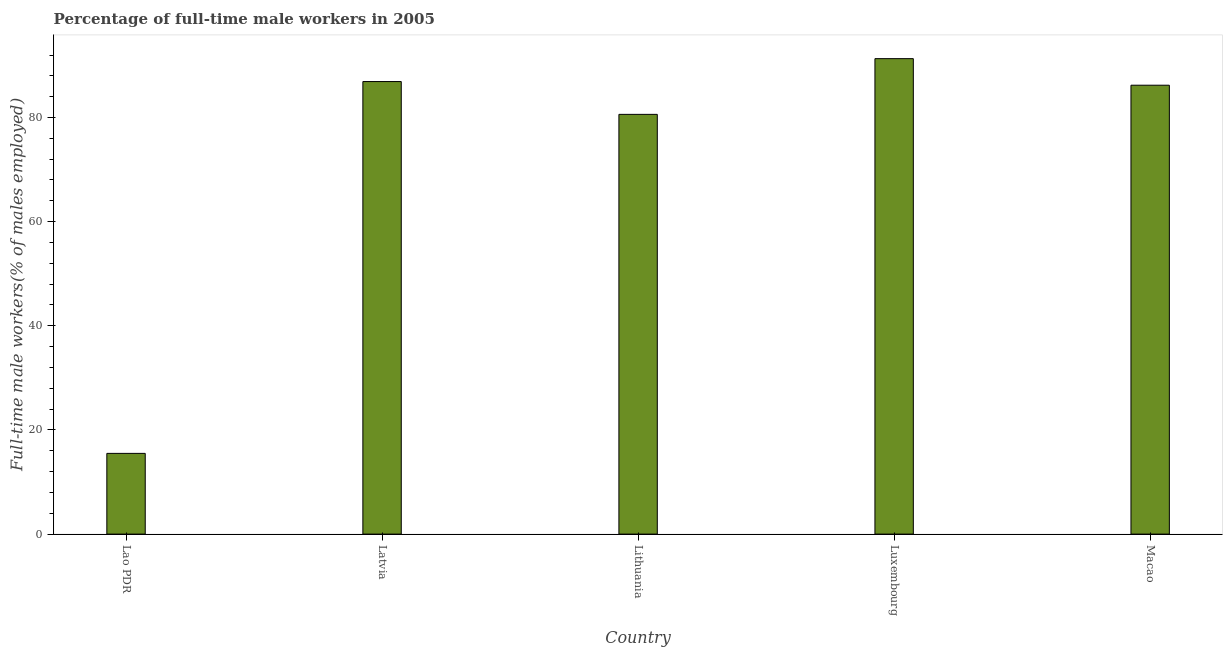What is the title of the graph?
Your answer should be compact. Percentage of full-time male workers in 2005. What is the label or title of the X-axis?
Give a very brief answer. Country. What is the label or title of the Y-axis?
Offer a very short reply. Full-time male workers(% of males employed). What is the percentage of full-time male workers in Luxembourg?
Offer a very short reply. 91.3. Across all countries, what is the maximum percentage of full-time male workers?
Your answer should be very brief. 91.3. Across all countries, what is the minimum percentage of full-time male workers?
Offer a very short reply. 15.5. In which country was the percentage of full-time male workers maximum?
Provide a short and direct response. Luxembourg. In which country was the percentage of full-time male workers minimum?
Provide a short and direct response. Lao PDR. What is the sum of the percentage of full-time male workers?
Offer a terse response. 360.5. What is the difference between the percentage of full-time male workers in Lao PDR and Macao?
Make the answer very short. -70.7. What is the average percentage of full-time male workers per country?
Provide a short and direct response. 72.1. What is the median percentage of full-time male workers?
Offer a very short reply. 86.2. In how many countries, is the percentage of full-time male workers greater than 64 %?
Ensure brevity in your answer.  4. Is the difference between the percentage of full-time male workers in Lithuania and Macao greater than the difference between any two countries?
Provide a succinct answer. No. What is the difference between the highest and the second highest percentage of full-time male workers?
Offer a very short reply. 4.4. Is the sum of the percentage of full-time male workers in Latvia and Lithuania greater than the maximum percentage of full-time male workers across all countries?
Provide a short and direct response. Yes. What is the difference between the highest and the lowest percentage of full-time male workers?
Provide a short and direct response. 75.8. In how many countries, is the percentage of full-time male workers greater than the average percentage of full-time male workers taken over all countries?
Ensure brevity in your answer.  4. How many bars are there?
Ensure brevity in your answer.  5. What is the difference between two consecutive major ticks on the Y-axis?
Give a very brief answer. 20. Are the values on the major ticks of Y-axis written in scientific E-notation?
Provide a short and direct response. No. What is the Full-time male workers(% of males employed) in Latvia?
Provide a succinct answer. 86.9. What is the Full-time male workers(% of males employed) in Lithuania?
Make the answer very short. 80.6. What is the Full-time male workers(% of males employed) of Luxembourg?
Give a very brief answer. 91.3. What is the Full-time male workers(% of males employed) of Macao?
Provide a short and direct response. 86.2. What is the difference between the Full-time male workers(% of males employed) in Lao PDR and Latvia?
Offer a very short reply. -71.4. What is the difference between the Full-time male workers(% of males employed) in Lao PDR and Lithuania?
Keep it short and to the point. -65.1. What is the difference between the Full-time male workers(% of males employed) in Lao PDR and Luxembourg?
Provide a succinct answer. -75.8. What is the difference between the Full-time male workers(% of males employed) in Lao PDR and Macao?
Your answer should be compact. -70.7. What is the difference between the Full-time male workers(% of males employed) in Latvia and Luxembourg?
Offer a very short reply. -4.4. What is the difference between the Full-time male workers(% of males employed) in Latvia and Macao?
Provide a succinct answer. 0.7. What is the difference between the Full-time male workers(% of males employed) in Lithuania and Macao?
Give a very brief answer. -5.6. What is the difference between the Full-time male workers(% of males employed) in Luxembourg and Macao?
Your response must be concise. 5.1. What is the ratio of the Full-time male workers(% of males employed) in Lao PDR to that in Latvia?
Your response must be concise. 0.18. What is the ratio of the Full-time male workers(% of males employed) in Lao PDR to that in Lithuania?
Your answer should be very brief. 0.19. What is the ratio of the Full-time male workers(% of males employed) in Lao PDR to that in Luxembourg?
Provide a succinct answer. 0.17. What is the ratio of the Full-time male workers(% of males employed) in Lao PDR to that in Macao?
Ensure brevity in your answer.  0.18. What is the ratio of the Full-time male workers(% of males employed) in Latvia to that in Lithuania?
Offer a very short reply. 1.08. What is the ratio of the Full-time male workers(% of males employed) in Latvia to that in Luxembourg?
Provide a succinct answer. 0.95. What is the ratio of the Full-time male workers(% of males employed) in Latvia to that in Macao?
Ensure brevity in your answer.  1.01. What is the ratio of the Full-time male workers(% of males employed) in Lithuania to that in Luxembourg?
Offer a very short reply. 0.88. What is the ratio of the Full-time male workers(% of males employed) in Lithuania to that in Macao?
Offer a very short reply. 0.94. What is the ratio of the Full-time male workers(% of males employed) in Luxembourg to that in Macao?
Give a very brief answer. 1.06. 